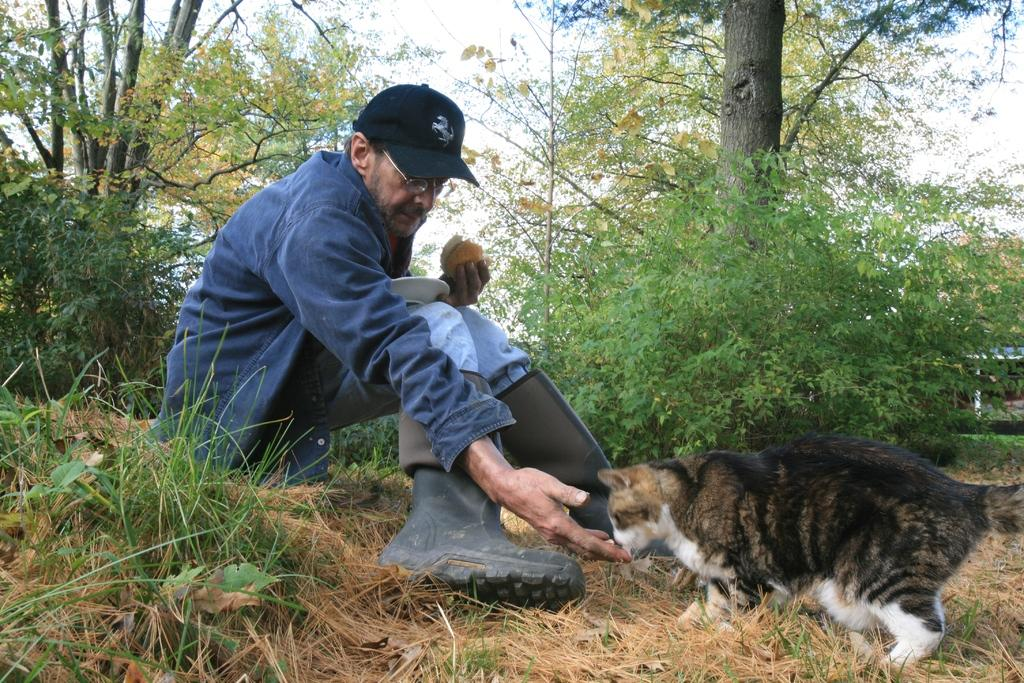What is the man in the image doing? The man is sitting on the grass in the image. What is the man holding in the image? The man is holding food and a plate in the image. What other living creature is present in the image? There is a cat in the image. What can be seen in the background of the image? There are plants and trees in the background of the image. What type of pan is being used to transport electricity in the image? There is no pan or any indication of electricity being transported in the image. 